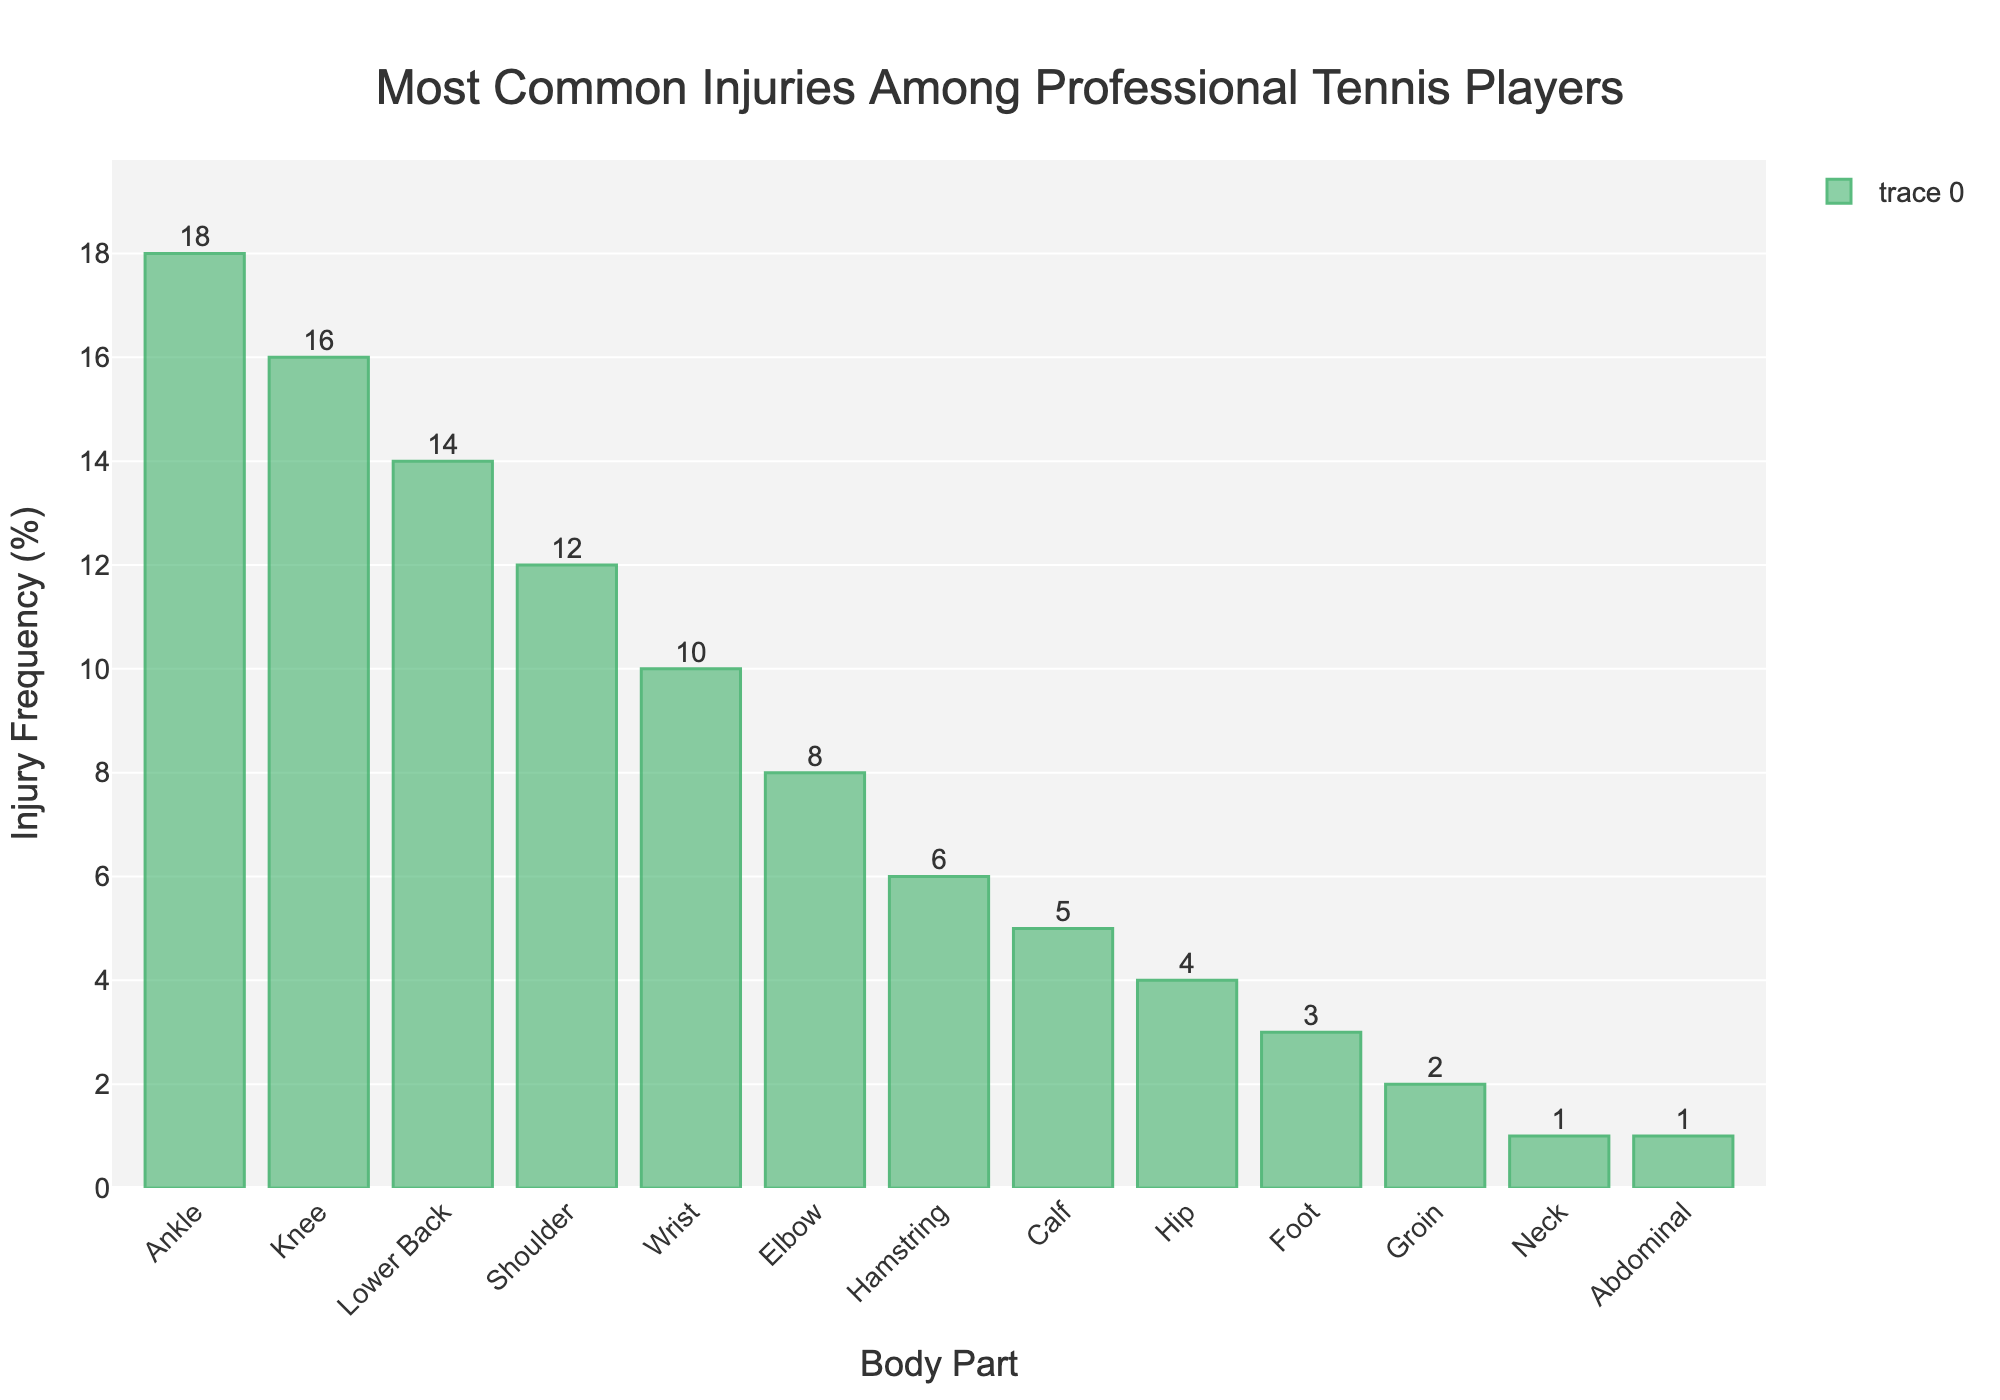What is the most common injury among professional tennis players? The tallest bar in the chart represents the most common injury. The bar for "Ankle" is the tallest, indicating it has the highest frequency.
Answer: Ankle Which body part has a higher injury frequency: Shoulder or Wrist? By comparing the height of the bars for "Shoulder" and "Wrist," we can see that the "Shoulder" bar is slightly taller, indicating a higher injury frequency.
Answer: Shoulder What's the total percentage of injuries for the top three most commonly injured body parts? The top three body parts are Ankle (18%), Knee (16%), and Lower Back (14%). Summing these percentages: 18 + 16 + 14 = 48.
Answer: 48% Among the injuries listed, which one has the lowest frequency, and what is it? The shortest bars indicate the lowest frequencies. The bars for "Neck" and "Abdominal" are the shortest, both at 1%.
Answer: Neck and Abdominal How much greater is the injury frequency for the Knee compared to the Calf? To find the difference, subtract the injury frequency of the Calf (5%) from the Knee (16%): 16 - 5 = 11%.
Answer: 11% Which injury has a frequency double that of the Elbow? The Elbow injury frequency is 8%. Doubling this gives 16%. The bar for "Knee" shows a frequency of 16%.
Answer: Knee Is the total percentage of injuries for the Upper Body (Shoulder, Wrist, Elbow, Neck, Abdominal) more or less than 30%? Add the percentages for Shoulder (12%), Wrist (10%), Elbow (8%), Neck (1%), and Abdominal (1%). The sum is 12 + 10 + 8 + 1 + 1 = 32%.
Answer: More What is the approximate difference in injury frequency between the injuries with the highest frequency and the injuries with the lowest frequency? The highest injury frequency is for the Ankle (18%), and the lowest frequencies are for Neck and Abdominal (1%). The difference is 18 - 1 = 17%.
Answer: 17% Which has a higher injury frequency: Hip or Foot, and by how much? Compare the bars for "Hip" and "Foot." Hip is at 4%, and Foot is at 3%. The difference is 4 - 3 = 1%.
Answer: Hip, 1% Are there more lower body injuries (Ankle, Knee, Hamstring, Calf, Hip, Foot, Groin) or upper body injuries (Shoulder, Wrist, Elbow, Neck, Abdominal)? Sum the frequencies: Lower Body = 18+16+6+5+4+3+2 = 54%, Upper Body = 12+10+8+1+1 = 32%. Lower Body injuries are more frequent.
Answer: Lower Body 